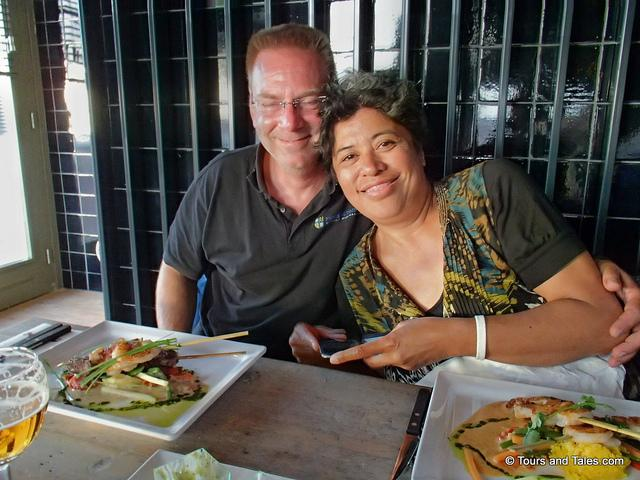What will this couple use to dine here?

Choices:
A) chopsticks
B) knives
C) forks
D) spoons chopsticks 